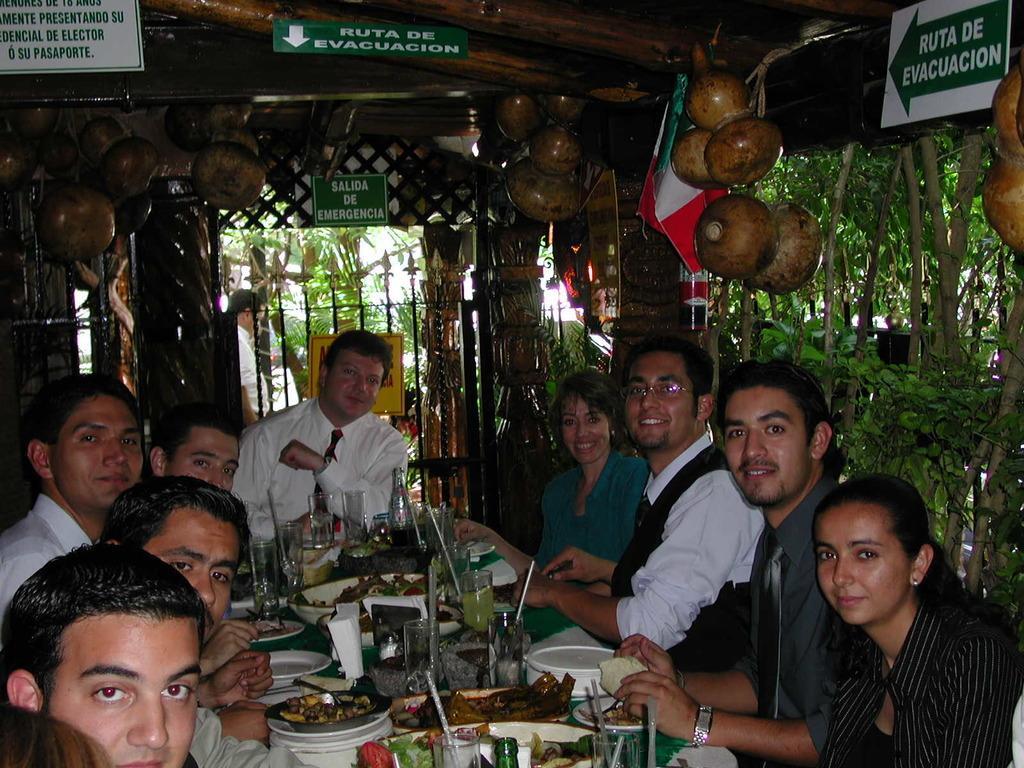Could you give a brief overview of what you see in this image? In this image I can see group of people sitting. In front I can see few food items in the bowls and plates. I can also see few glasses, spoons, plates on the table. Background I can see few plants and trees in green color and few boards in green color. 